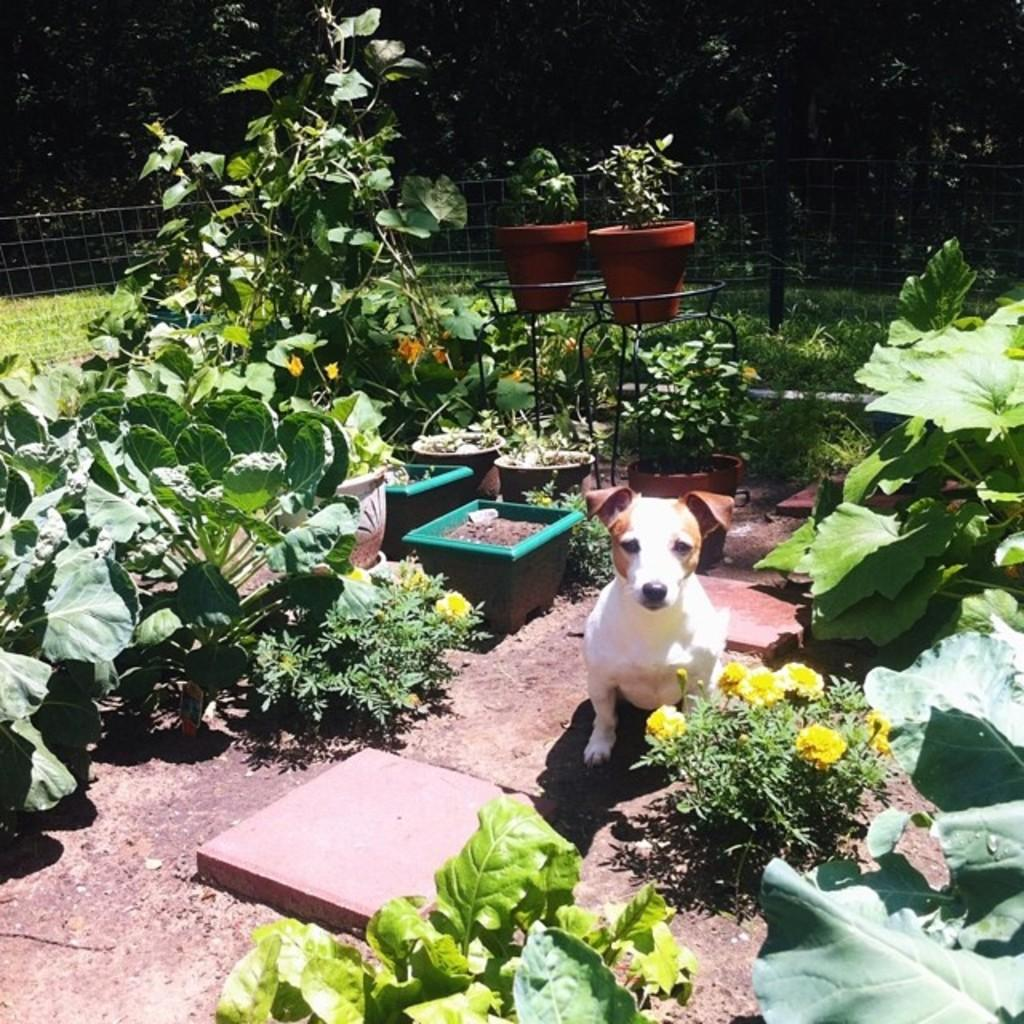What is the main subject in the center of the image? There is a dog in the center of the image. What other elements can be seen in the image besides the dog? There are plants and a fencing visible in the image. What can be seen in the background of the image? There are trees in the background of the image. What type of twig is the dog holding in its mouth in the image? There is no twig visible in the dog's mouth in the image. Can you tell me how fast the dog is running in the image? The image does not show the dog running, so it is not possible to determine its speed. 